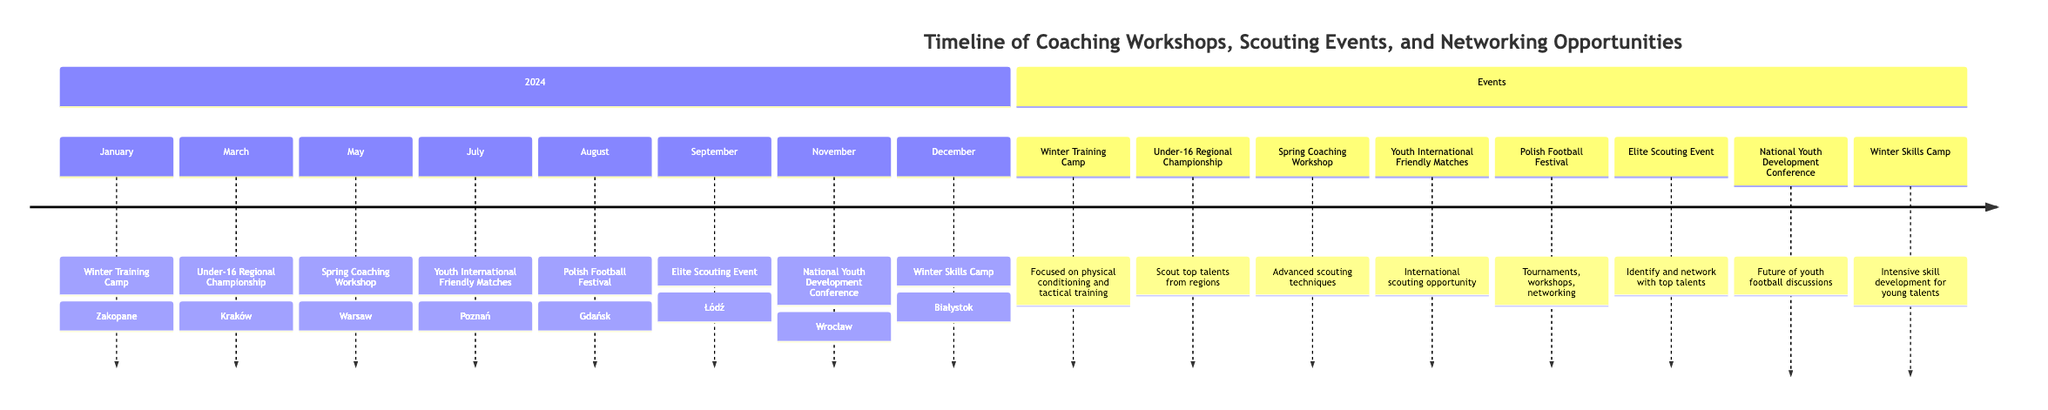What is the first event in the timeline? The first event listed in the timeline is in January, titled "Winter Training Camp."
Answer: Winter Training Camp In which month does the National Youth Development Conference occur? Looking at the timeline, the National Youth Development Conference takes place in November.
Answer: November How many scouting-related events are scheduled throughout the year? The events related to scouting include the Under-16 Regional Championship, Youth International Friendly Matches, Elite Scouting Event, totaling three events.
Answer: 3 What type of event is scheduled for August? The event scheduled for August is the "Polish Football Festival," which includes youth tournaments, workshops, and networking opportunities.
Answer: Polish Football Festival Which event is aimed specifically at skill development? The "Winter Skills Camp" is explicitly focused on intensive skill development for young talents.
Answer: Winter Skills Camp What is the primary focus of the Spring Coaching Workshop? The Spring Coaching Workshop focuses on advanced scouting techniques, according to the timeline details provided.
Answer: Advanced scouting techniques Which two events take place in the same month? The timeline shows that there are no two events that occur in the same month; each event is uniquely scheduled to a different month.
Answer: None Which event provides an opportunity to scout the best young talents? The Elite Scouting Event is specified as an exclusive event for scouts to identify and network with top young talents.
Answer: Elite Scouting Event What is the location of the Winter Training Camp? The Winter Training Camp is located in Zakopane, Poland.
Answer: Zakopane 